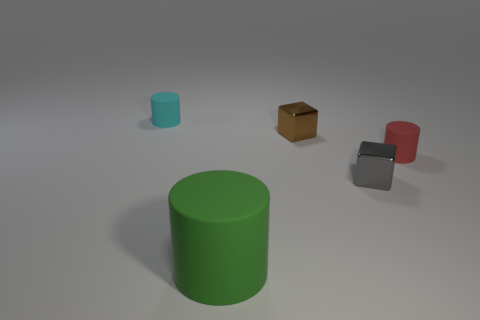What shape is the tiny matte thing on the right side of the cyan cylinder?
Your answer should be very brief. Cylinder. Are the green cylinder and the tiny cube that is in front of the tiny red rubber cylinder made of the same material?
Your answer should be very brief. No. Is the cyan thing the same shape as the large object?
Your answer should be compact. Yes. There is a cyan thing that is the same shape as the green matte object; what is it made of?
Give a very brief answer. Rubber. There is a rubber thing that is both behind the gray cube and in front of the small cyan rubber object; what color is it?
Your answer should be compact. Red. What is the color of the big thing?
Make the answer very short. Green. Are there any blue matte things of the same shape as the brown shiny thing?
Provide a succinct answer. No. There is a cylinder in front of the red rubber cylinder; how big is it?
Make the answer very short. Large. What material is the cyan object that is the same size as the red thing?
Give a very brief answer. Rubber. Are there more tiny green matte things than small gray shiny cubes?
Make the answer very short. No. 